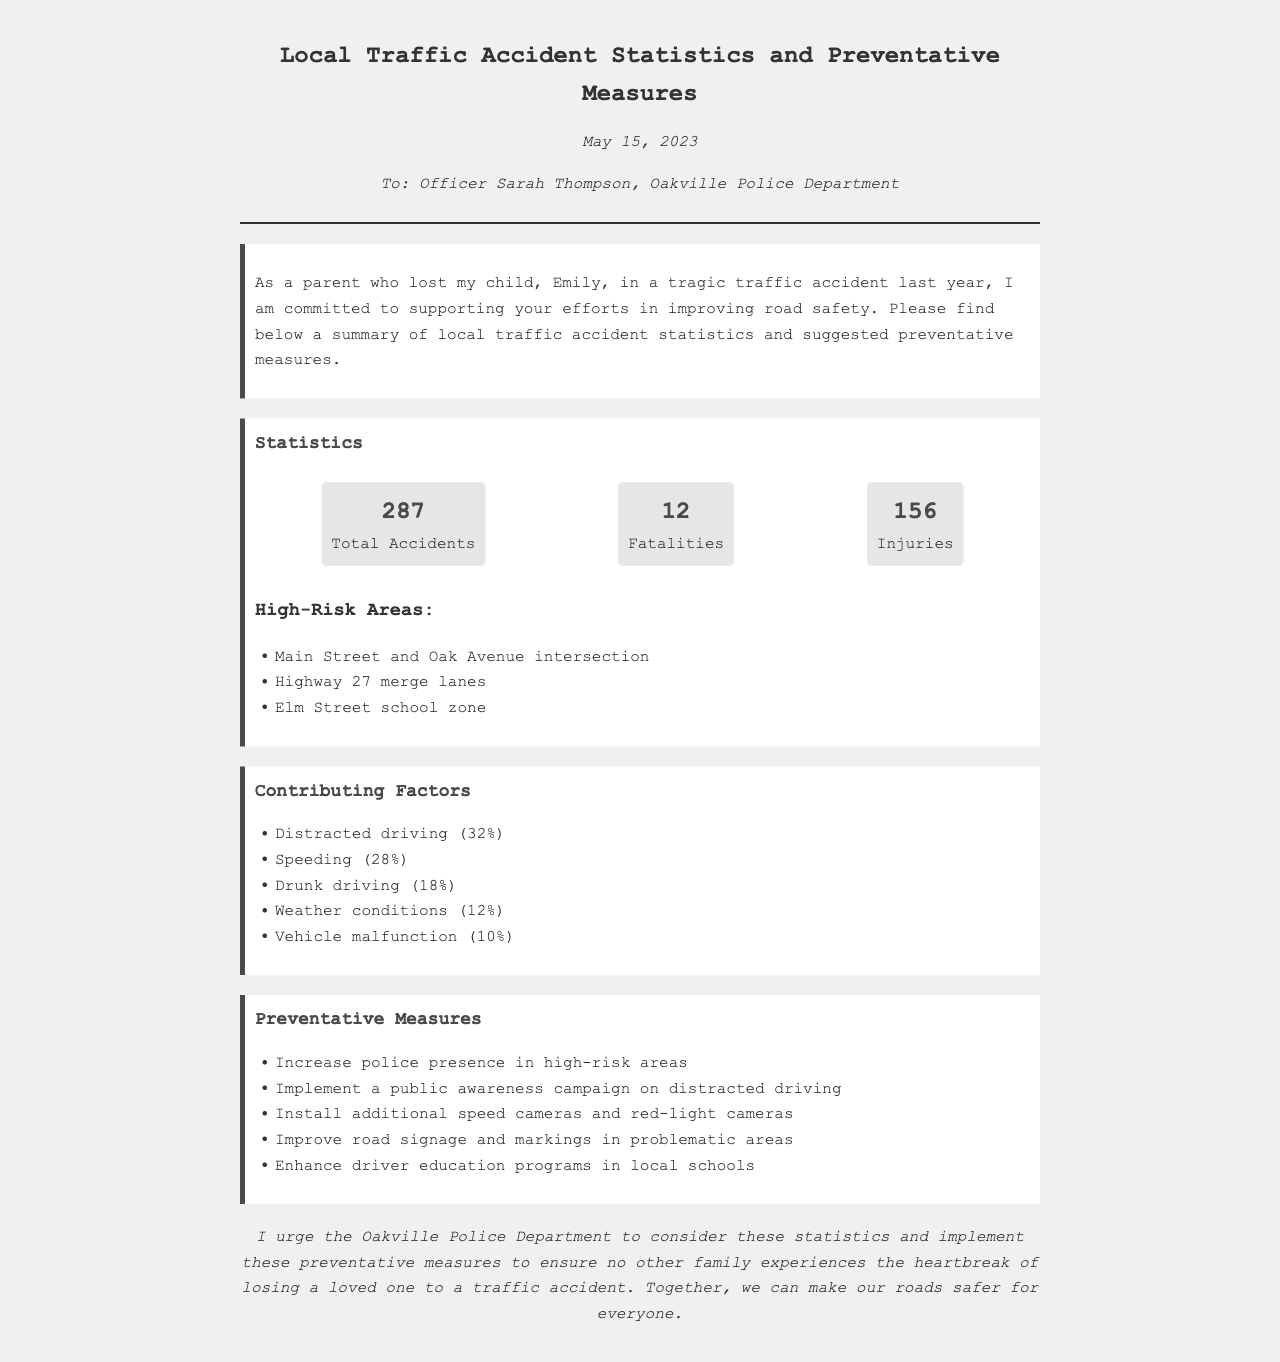what is the total number of accidents? The total number of accidents is stated in the statistics section as 287.
Answer: 287 how many fatalities were reported? The number of fatalities reported in the statistics section is 12.
Answer: 12 what percentage of accidents were due to distracted driving? The contributing factors indicate that 32% of accidents were due to distracted driving.
Answer: 32% which area is identified as a high-risk zone for accidents? The document lists the Main Street and Oak Avenue intersection as a high-risk area.
Answer: Main Street and Oak Avenue intersection what measure is suggested for improving road safety in high-risk areas? One of the suggested measures is to increase police presence in high-risk areas.
Answer: Increase police presence how many total injuries were recorded? The statistics section indicates that there were 156 total injuries.
Answer: 156 which contributing factor has the second highest percentage? Speeding is identified as the contributing factor with the second highest percentage at 28%.
Answer: Speeding what date is the fax dated? The date on the fax is May 15, 2023.
Answer: May 15, 2023 who is the recipient of the fax? The fax is addressed to Officer Sarah Thompson of the Oakville Police Department.
Answer: Officer Sarah Thompson 